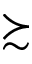Convert formula to latex. <formula><loc_0><loc_0><loc_500><loc_500>\succ s i m</formula> 